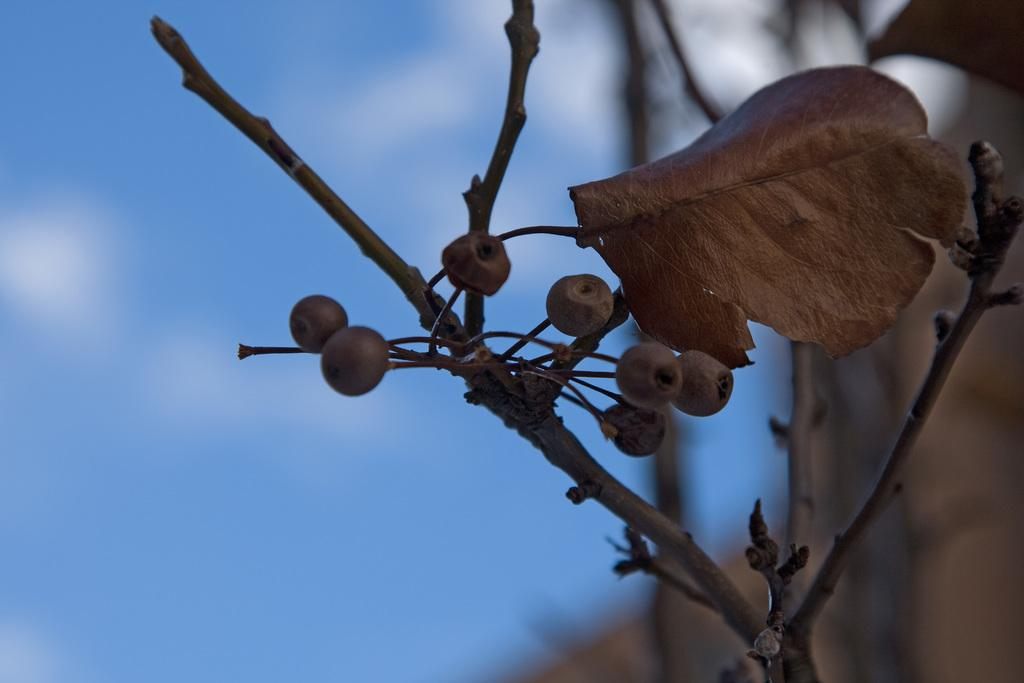What type of fruit or vegetable is present in the image? There are berries in the image. What part of a plant can be seen in the image? There is a leaf and stems in the image. How would you describe the background of the image? The background of the image is blurred. What can be seen in the sky in the image? The sky is visible in the image, and clouds are present. What type of lettuce is growing next to the cactus in the image? There is no lettuce or cactus present in the image; it only contains berries, a leaf, and stems. 